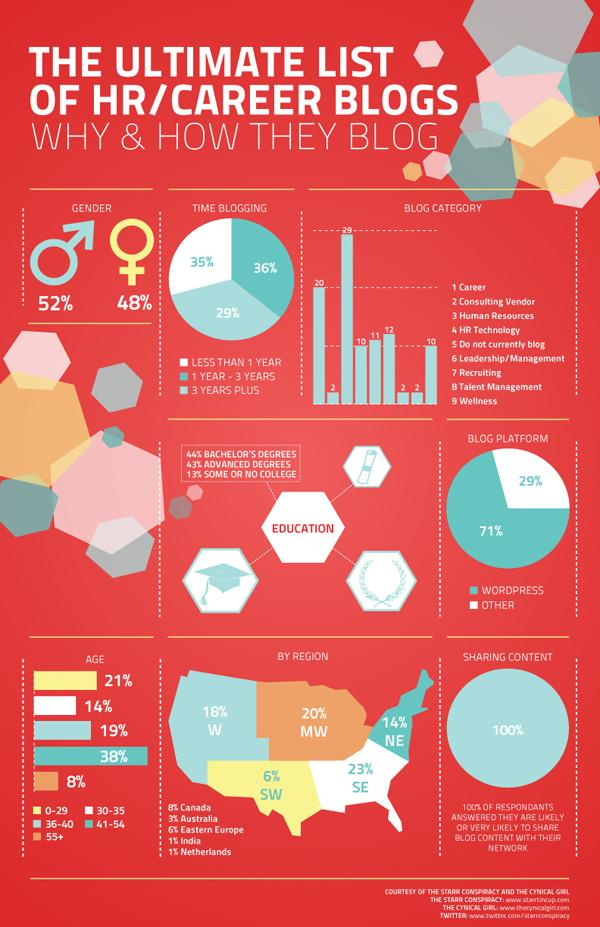List a handful of essential elements in this visual. Wordpress is the platform that owns the majority of blog traffic. According to the data, the majority of HR and career blogs are written and driven by males, with a proportion of 52%. 